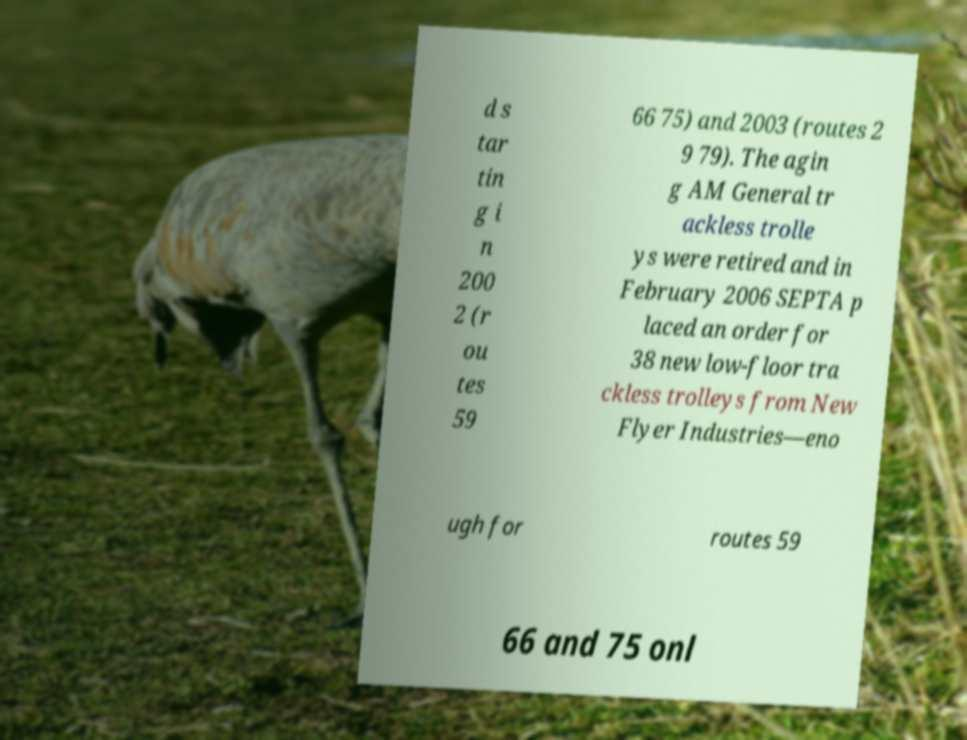Can you read and provide the text displayed in the image?This photo seems to have some interesting text. Can you extract and type it out for me? d s tar tin g i n 200 2 (r ou tes 59 66 75) and 2003 (routes 2 9 79). The agin g AM General tr ackless trolle ys were retired and in February 2006 SEPTA p laced an order for 38 new low-floor tra ckless trolleys from New Flyer Industries—eno ugh for routes 59 66 and 75 onl 